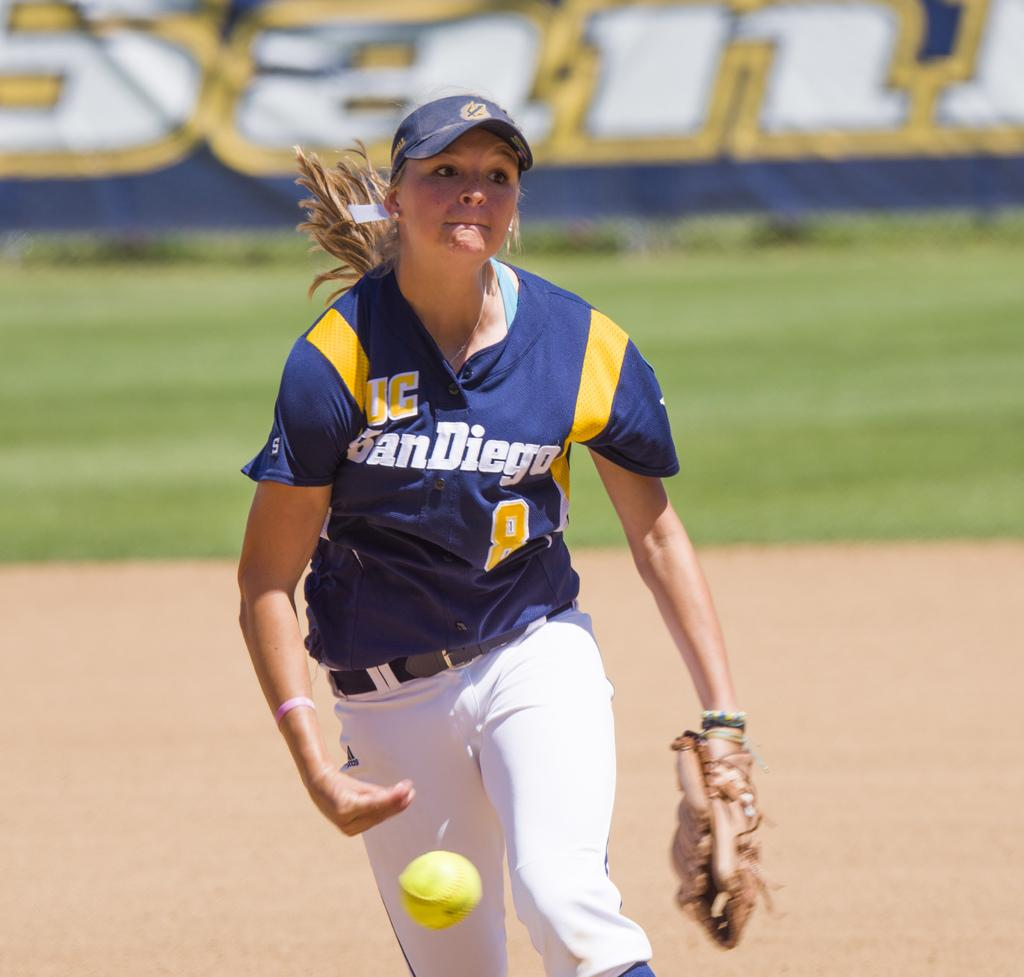<image>
Give a short and clear explanation of the subsequent image. a player with the name san diego on their jersey 